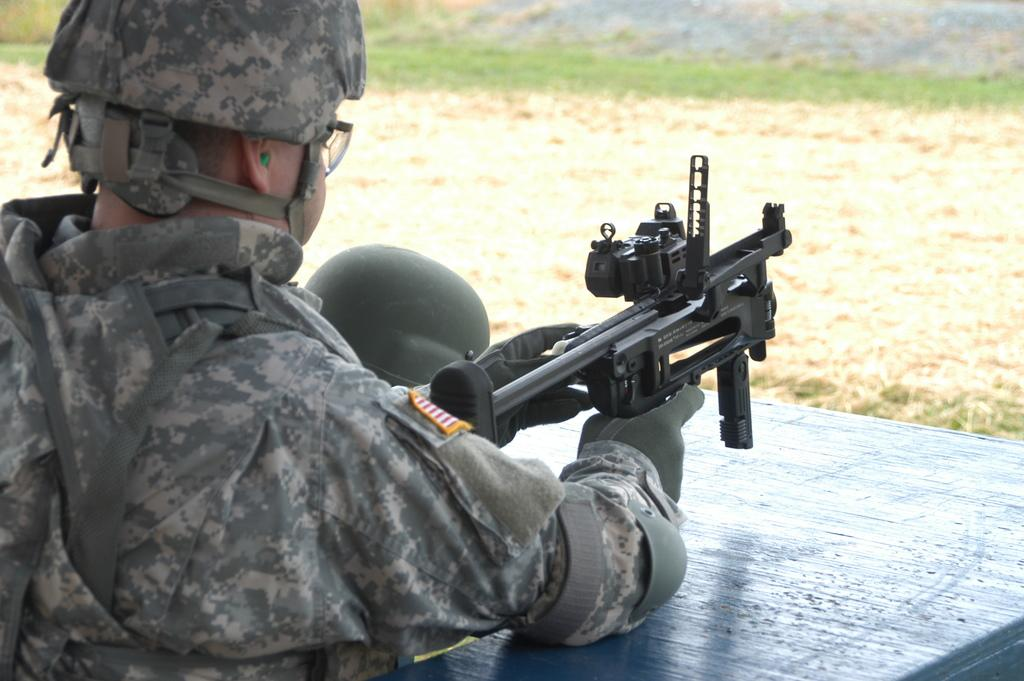What is the main subject of the image? There is a person in the image. What is the person wearing? The person is wearing a uniform and a helmet. What is the person holding in the image? The person is holding a black-colored gun. What can be seen in the background of the image? There is ground visible in the background of the image, and there is grass on the ground. What type of knowledge is the maid sharing with the person in the image? There is no maid present in the image, and therefore no knowledge can be shared. What is the person using to brush their teeth in the image? There is no toothbrush or any indication of brushing teeth in the image. 